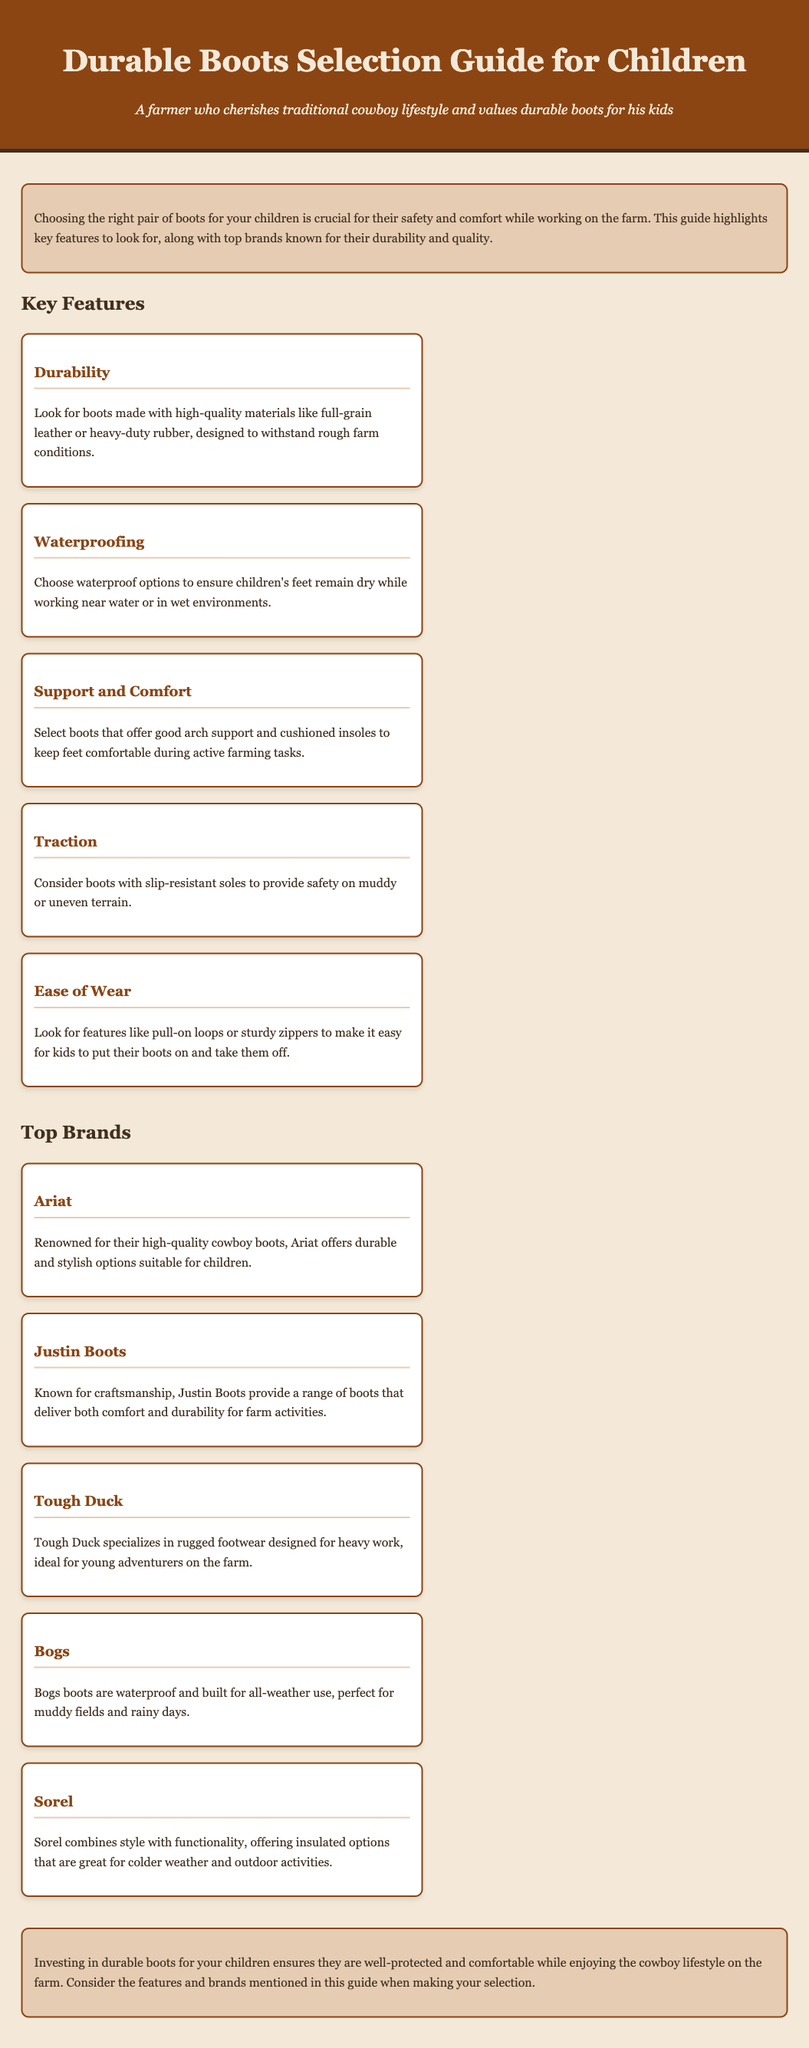What are the key features to look for in children's boots? The document lists five key features: Durability, Waterproofing, Support and Comfort, Traction, and Ease of Wear.
Answer: Durability, Waterproofing, Support and Comfort, Traction, Ease of Wear Which brand is renowned for high-quality cowboy boots? The document states that Ariat is renowned for their high-quality cowboy boots suitable for children.
Answer: Ariat What is a recommended feature for boots to keep kids' feet dry? The document recommends waterproof options as a feature to keep kids' feet dry.
Answer: Waterproof options How many top brands are listed in the document? The document mentions five top brands known for their durable boots.
Answer: Five Which brand specializes in rugged footwear for heavy work? According to the document, Tough Duck specializes in rugged footwear designed for heavy work.
Answer: Tough Duck What is mentioned as a key feature for boots to ensure comfort during active tasks? The document specifies good arch support and cushioned insoles as key features for comfort.
Answer: Good arch support and cushioned insoles What type of boots are Bogs known for? The document states that Bogs boots are waterproof and built for all-weather use.
Answer: Waterproof and built for all-weather use What should be considered to ensure safety on muddy terrain? The document suggests considering boots with slip-resistant soles for safety on muddy terrain.
Answer: Slip-resistant soles 